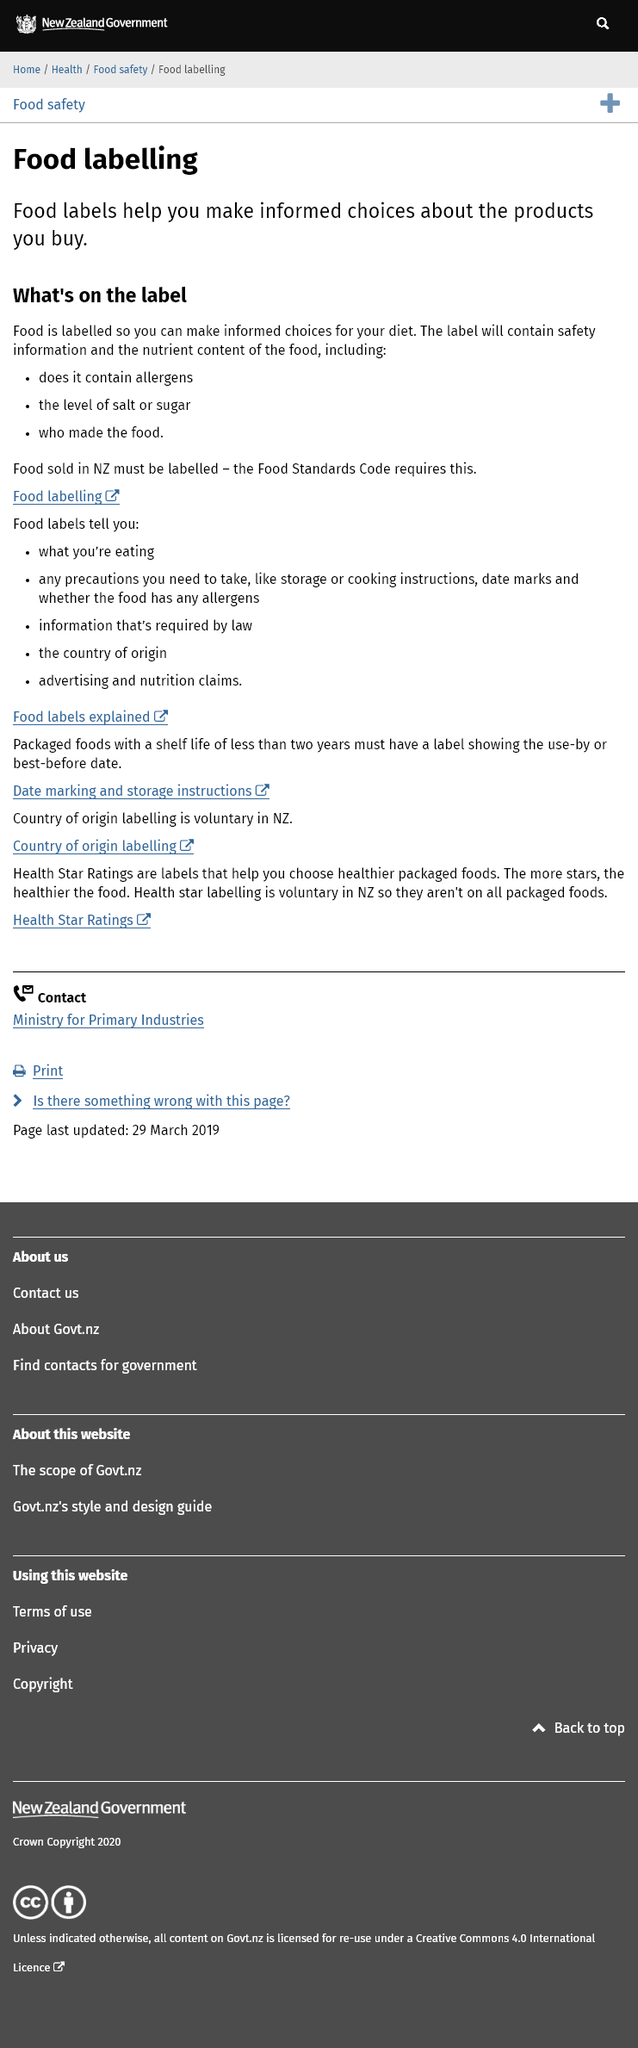Mention a couple of crucial points in this snapshot. The regulation requires that all packaged foods with a shelf life of less than two years must have a label showing the use by or best before date. Health star rating is not mandatory in New Zealand; it is voluntary. In New Zealand, the Food Standards Code establishes the regulations for food labels. Food labels provide important information such as the ingredients and nutritional content of the product, precautions to be taken when consuming the item, date marks for freshness, cooking and storage instructions, country of origin, allergens, and any required information by law. Foods are labeled to provide consumers with the information they need to make informed choices about their diet and to highlight important safety information. 